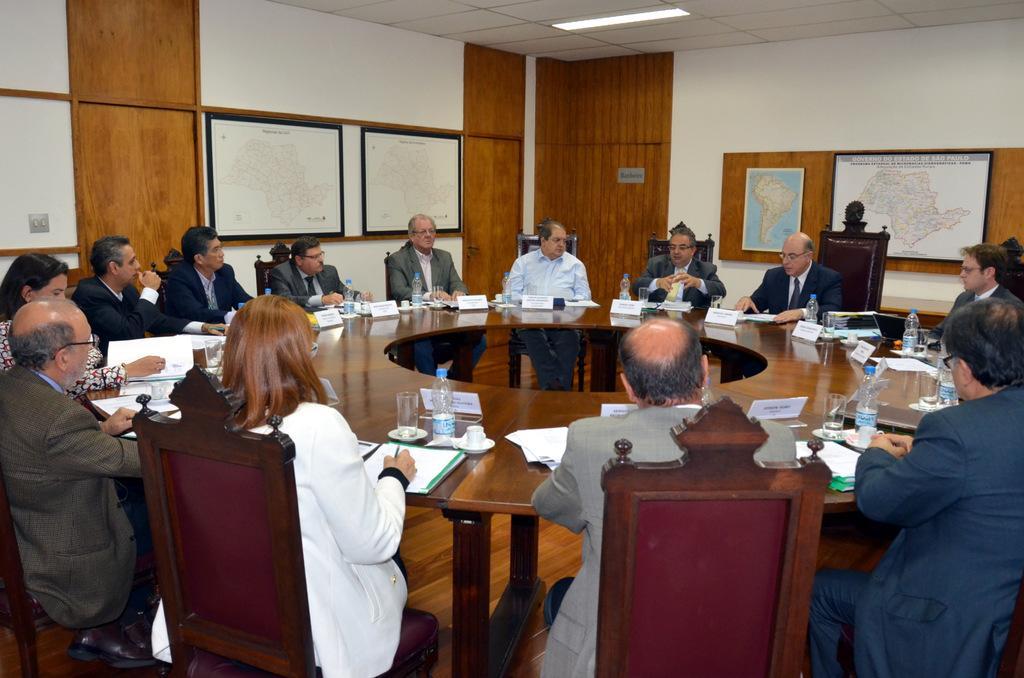How would you summarize this image in a sentence or two? In this image I can see number of people are sitting on chairs. Here on this round table I can see few bottles. On this wall I can see maps. 